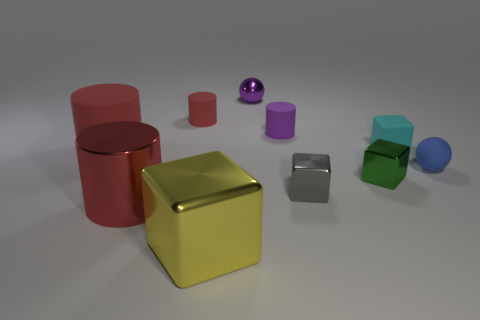Is the metal cylinder the same color as the large rubber object?
Your answer should be compact. Yes. What shape is the big matte object that is the same color as the shiny cylinder?
Ensure brevity in your answer.  Cylinder. What is the size of the shiny object that is the same color as the big matte cylinder?
Keep it short and to the point. Large. How many other things are the same shape as the big yellow thing?
Ensure brevity in your answer.  3. Do the shiny block right of the tiny gray block and the metal cube that is left of the small purple shiny sphere have the same size?
Your response must be concise. No. How many cylinders are tiny rubber objects or gray metallic objects?
Provide a short and direct response. 2. How many shiny objects are red cubes or large red cylinders?
Provide a succinct answer. 1. The other red metal thing that is the same shape as the small red object is what size?
Give a very brief answer. Large. Is there any other thing that has the same size as the yellow thing?
Your answer should be very brief. Yes. There is a blue sphere; is its size the same as the red cylinder in front of the small blue rubber sphere?
Provide a succinct answer. No. 